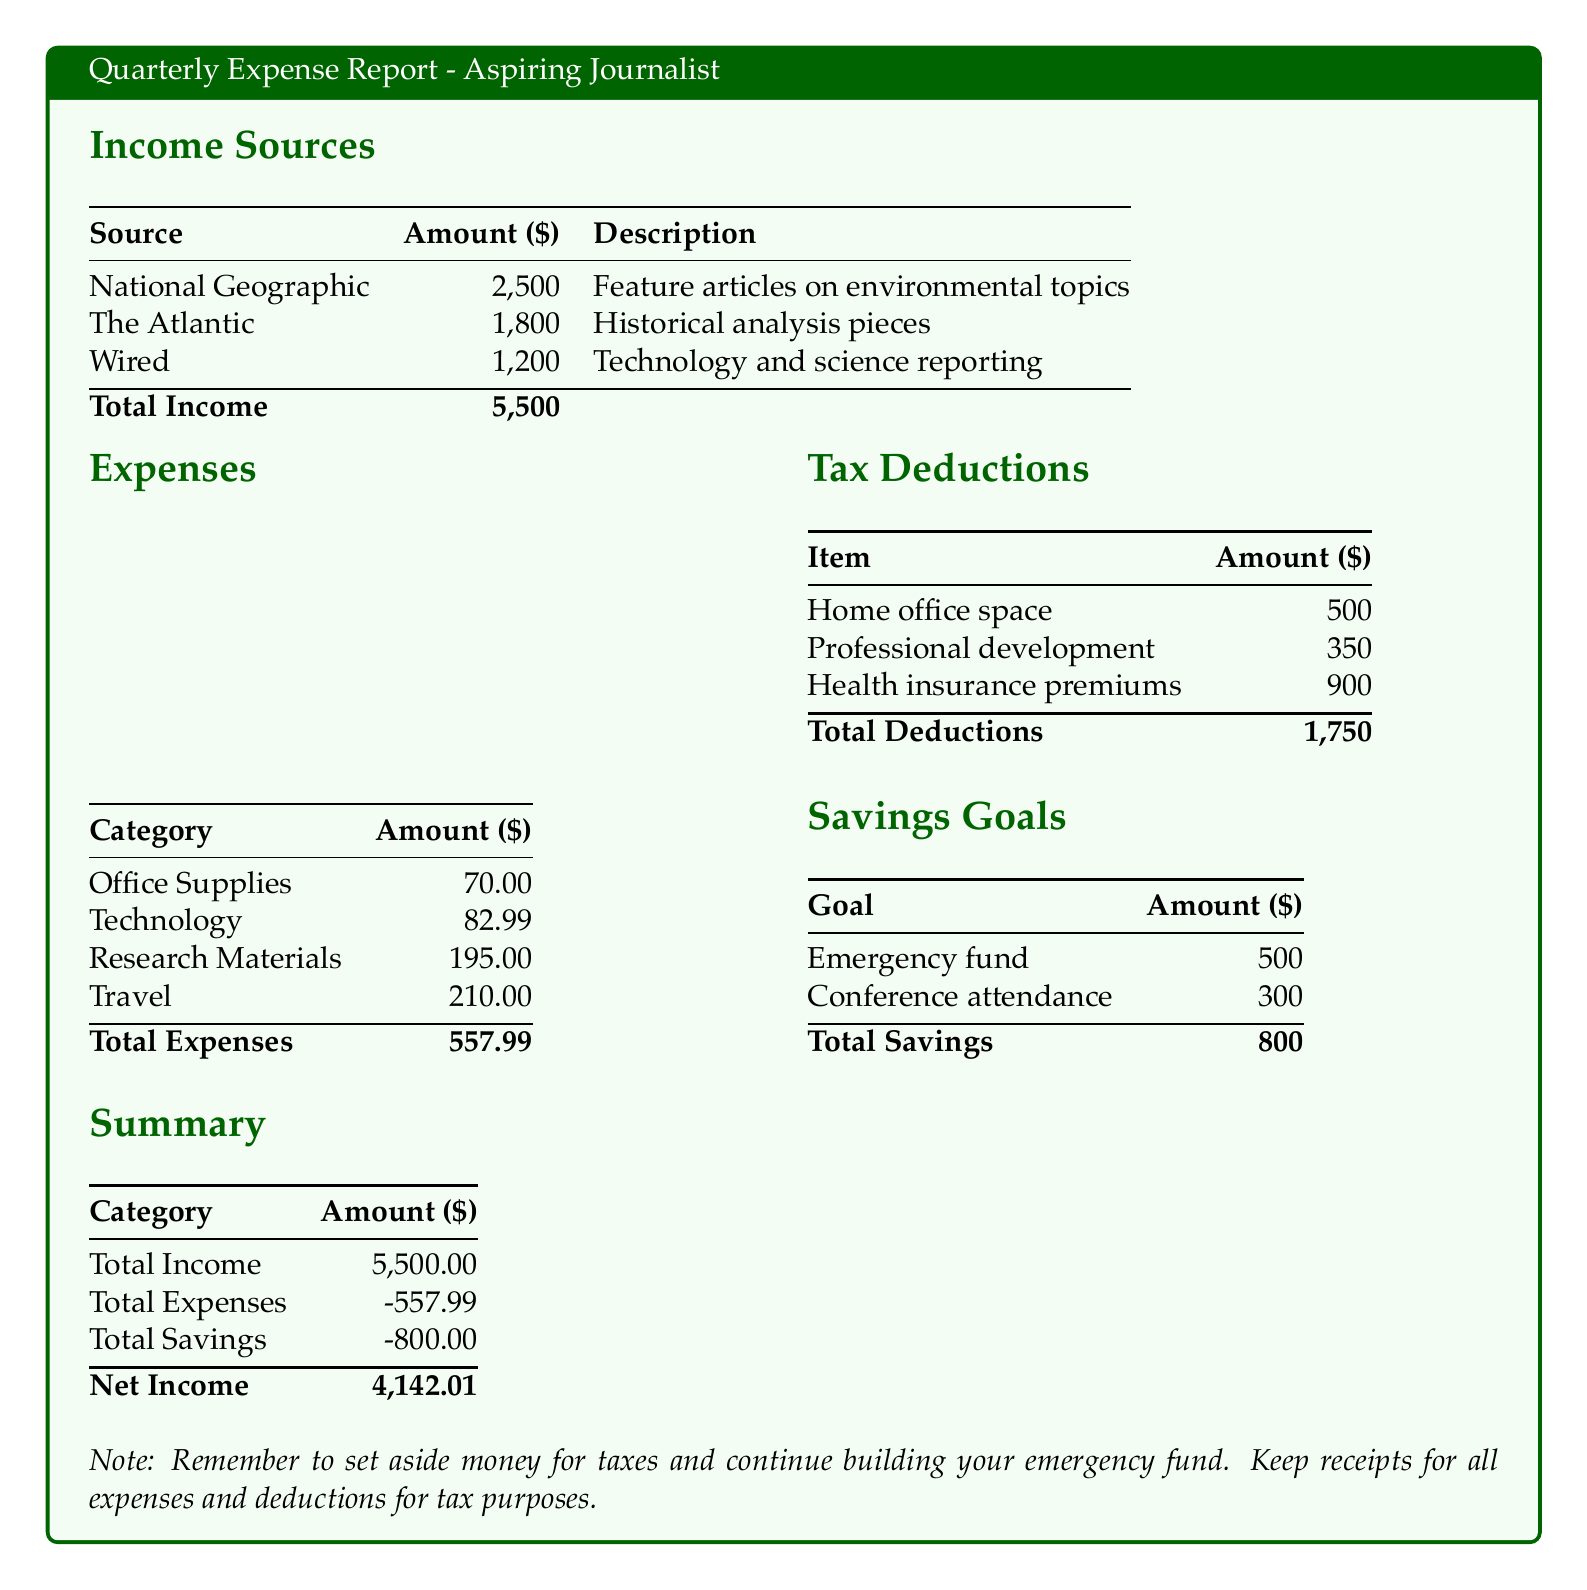What is the total income? The total income is the sum of all income sources listed, which is $2,500 + $1,800 + $1,200 = $5,500.
Answer: $5,500 What is the largest expense category? The largest expense category listed is Travel at $210.
Answer: Travel How much did the journalist spend on research materials? The expense listed under Research Materials shows an amount of $195.
Answer: $195 What are the total tax deductions? The total deductions amount is calculated by adding up the individual tax deduction items, which totals $500 + $350 + $900 = $1,750.
Answer: $1,750 What is the net income? The net income is calculated by subtracting total expenses and total savings from total income, resulting in $5,500 - $557.99 - $800 = $4,142.01.
Answer: $4,142.01 What is the saving goal for conference attendance? The document specifies a saving goal for conference attendance amounting to $300.
Answer: $300 How much is budgeted for the emergency fund? The budgeted amount for the emergency fund is listed as $500.
Answer: $500 What is the total amount spent on office supplies and technology combined? The total combined for office supplies ($70) and technology ($82.99) amounts to $70 + $82.99 = $152.99.
Answer: $152.99 What is the total savings indicated in the report? The total savings is calculated by summing up all the individual savings goals, which is $500 + $300 = $800.
Answer: $800 